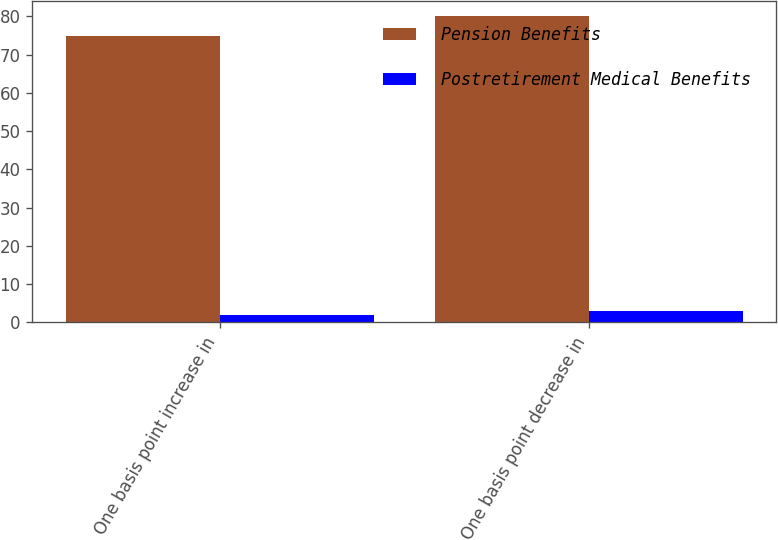Convert chart. <chart><loc_0><loc_0><loc_500><loc_500><stacked_bar_chart><ecel><fcel>One basis point increase in<fcel>One basis point decrease in<nl><fcel>Pension Benefits<fcel>75<fcel>80<nl><fcel>Postretirement Medical Benefits<fcel>2<fcel>3<nl></chart> 